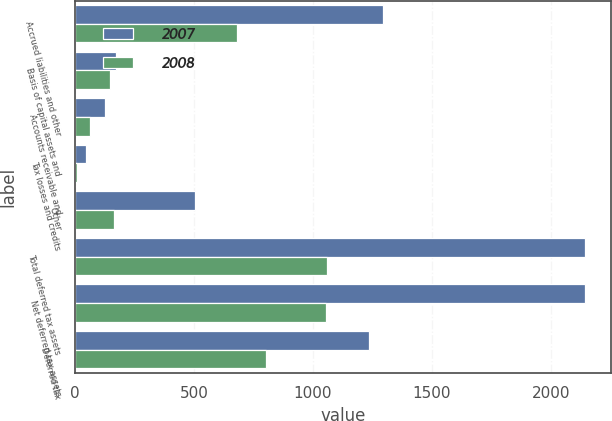Convert chart. <chart><loc_0><loc_0><loc_500><loc_500><stacked_bar_chart><ecel><fcel>Accrued liabilities and other<fcel>Basis of capital assets and<fcel>Accounts receivable and<fcel>Tax losses and credits<fcel>Other<fcel>Total deferred tax assets<fcel>Net deferred tax assets<fcel>Deferred tax<nl><fcel>2007<fcel>1295<fcel>173<fcel>126<fcel>47<fcel>503<fcel>2144<fcel>2144<fcel>1234<nl><fcel>2008<fcel>679<fcel>146<fcel>64<fcel>8<fcel>161<fcel>1058<fcel>1053<fcel>803<nl></chart> 